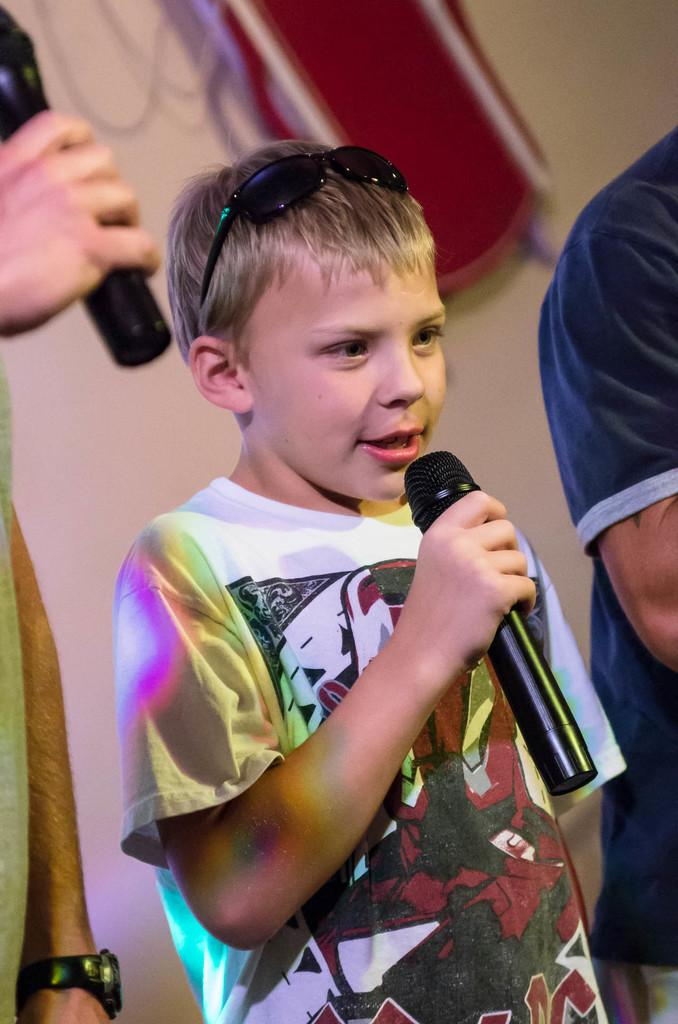What is the main subject of the image? The main subject of the image is a kid. What is the kid doing in the image? The kid is standing and holding a mic in his hand. Are there any other people in the image? Yes, there are other people standing beside the kid. What type of pen is the kid using to write on the credit card in the image? There is no pen or credit card present in the image; the kid is holding a mic. Can you tell me how many turkeys are visible in the image? There are no turkeys present in the image. 